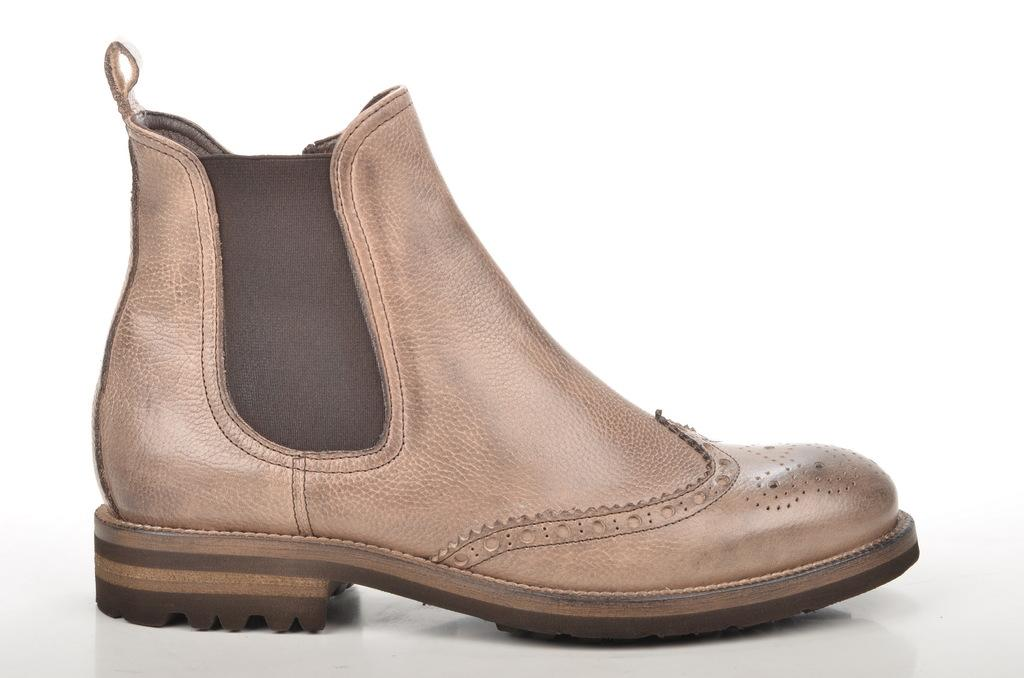What object is present in the image? There is a boot in the image. Where is the boot located? The boot is placed on a surface. What type of potato is being served in the lunchroom in the image? There is no lunchroom or potato present in the image; it only features a boot placed on a surface. 